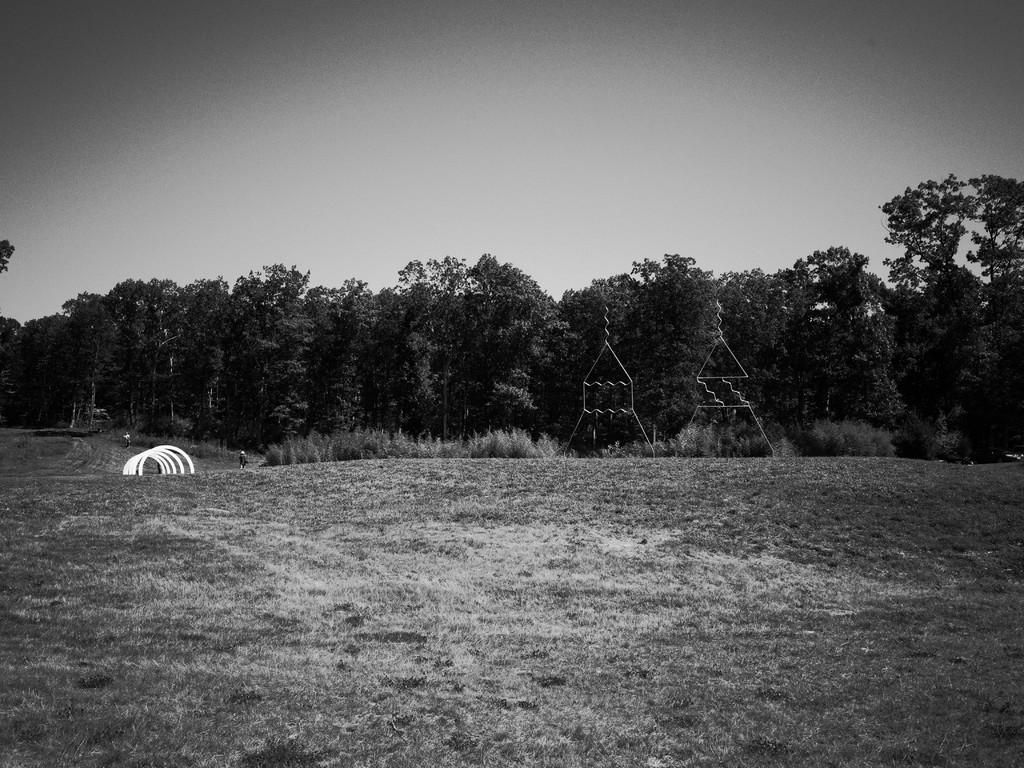What is the color scheme of the image? The image is black and white. Who or what can be seen in the image? There are people in the image. What type of natural environment is present in the image? There are trees and grass in the image. What else can be found on the ground in the image? There are other objects on the ground in the image. What is visible in the background of the image? The sky is visible in the background of the image. What type of finger can be seen in the image? There are no fingers present in the image, as it is a black and white image with people, trees, grass, and other objects on the ground. 